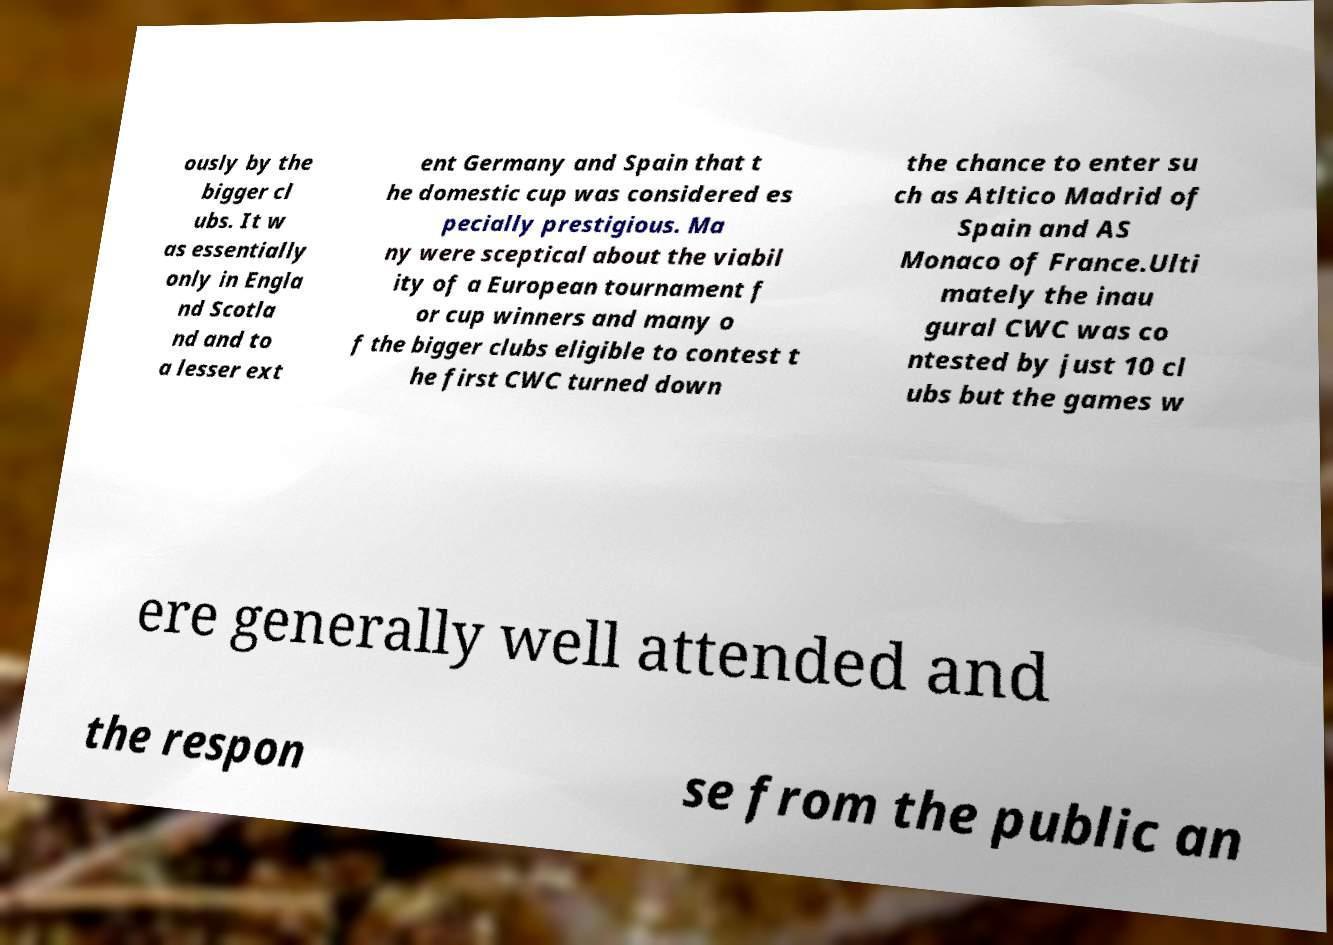There's text embedded in this image that I need extracted. Can you transcribe it verbatim? ously by the bigger cl ubs. It w as essentially only in Engla nd Scotla nd and to a lesser ext ent Germany and Spain that t he domestic cup was considered es pecially prestigious. Ma ny were sceptical about the viabil ity of a European tournament f or cup winners and many o f the bigger clubs eligible to contest t he first CWC turned down the chance to enter su ch as Atltico Madrid of Spain and AS Monaco of France.Ulti mately the inau gural CWC was co ntested by just 10 cl ubs but the games w ere generally well attended and the respon se from the public an 